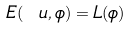Convert formula to latex. <formula><loc_0><loc_0><loc_500><loc_500>E ( \ u , \phi ) = L ( \phi )</formula> 